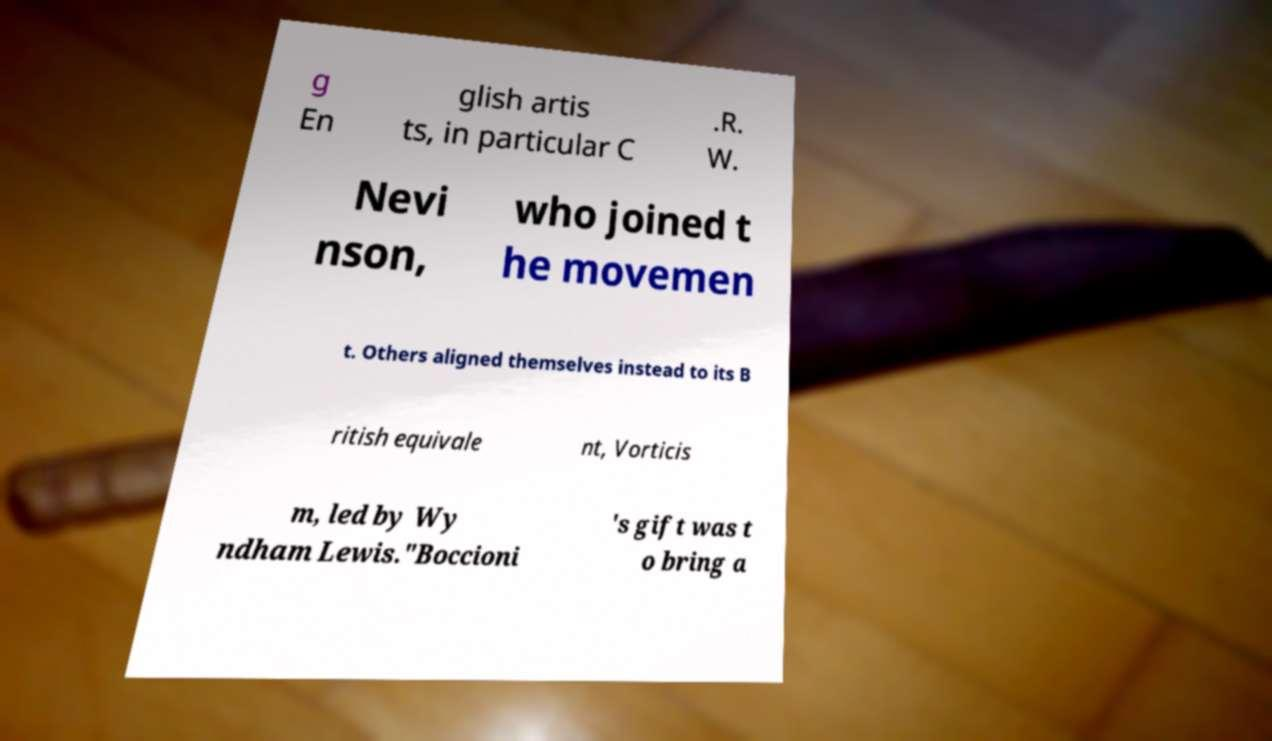Could you assist in decoding the text presented in this image and type it out clearly? g En glish artis ts, in particular C .R. W. Nevi nson, who joined t he movemen t. Others aligned themselves instead to its B ritish equivale nt, Vorticis m, led by Wy ndham Lewis."Boccioni 's gift was t o bring a 